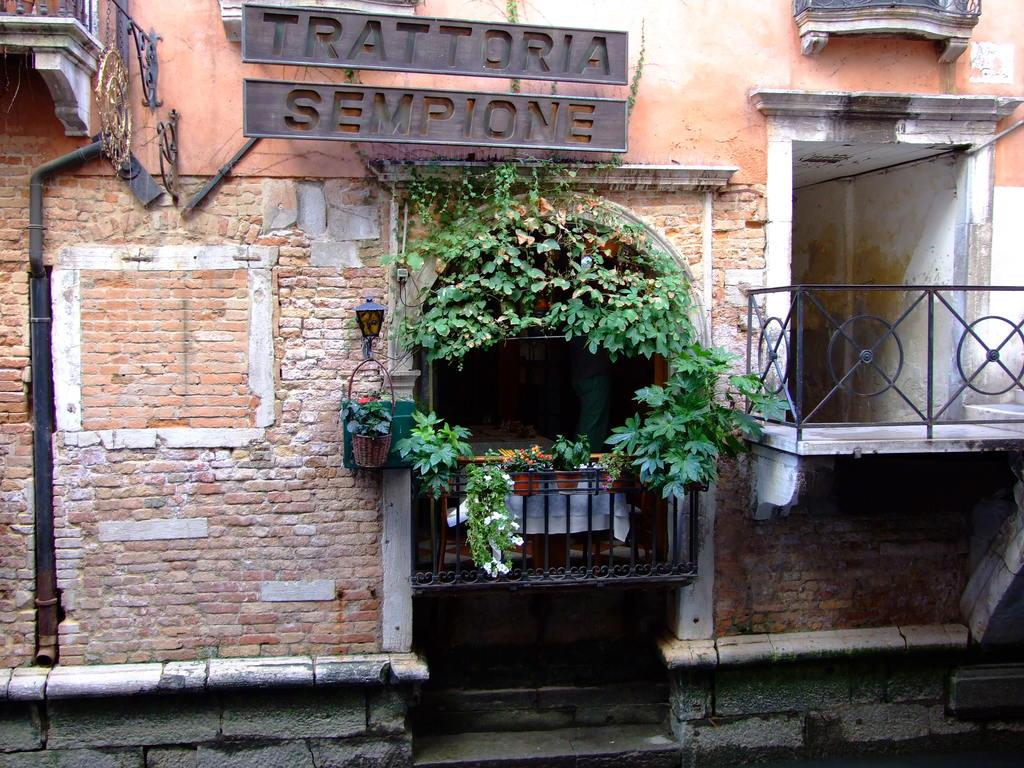What is the main subject of the image? There is an image, but no specific details are provided about its content. What type of structure can be seen on the left and right corners of the image? There are metal railings on the left and right corners of the image. What type of vegetation is present in the image? Potted plants and flowers are visible in the image. Is there any text present in the image? Yes, there is text in the image. What type of church is visible in the image? There is no church present in the image. How many screws are visible in the image? There is no mention of screws in the provided facts, so we cannot determine how many are visible in the image. 